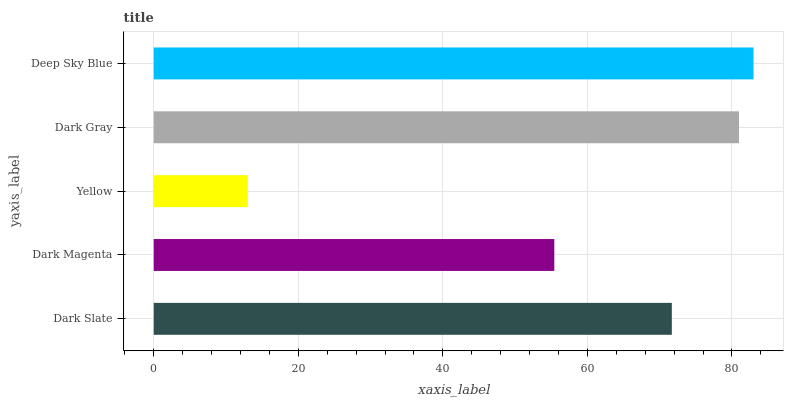Is Yellow the minimum?
Answer yes or no. Yes. Is Deep Sky Blue the maximum?
Answer yes or no. Yes. Is Dark Magenta the minimum?
Answer yes or no. No. Is Dark Magenta the maximum?
Answer yes or no. No. Is Dark Slate greater than Dark Magenta?
Answer yes or no. Yes. Is Dark Magenta less than Dark Slate?
Answer yes or no. Yes. Is Dark Magenta greater than Dark Slate?
Answer yes or no. No. Is Dark Slate less than Dark Magenta?
Answer yes or no. No. Is Dark Slate the high median?
Answer yes or no. Yes. Is Dark Slate the low median?
Answer yes or no. Yes. Is Yellow the high median?
Answer yes or no. No. Is Yellow the low median?
Answer yes or no. No. 